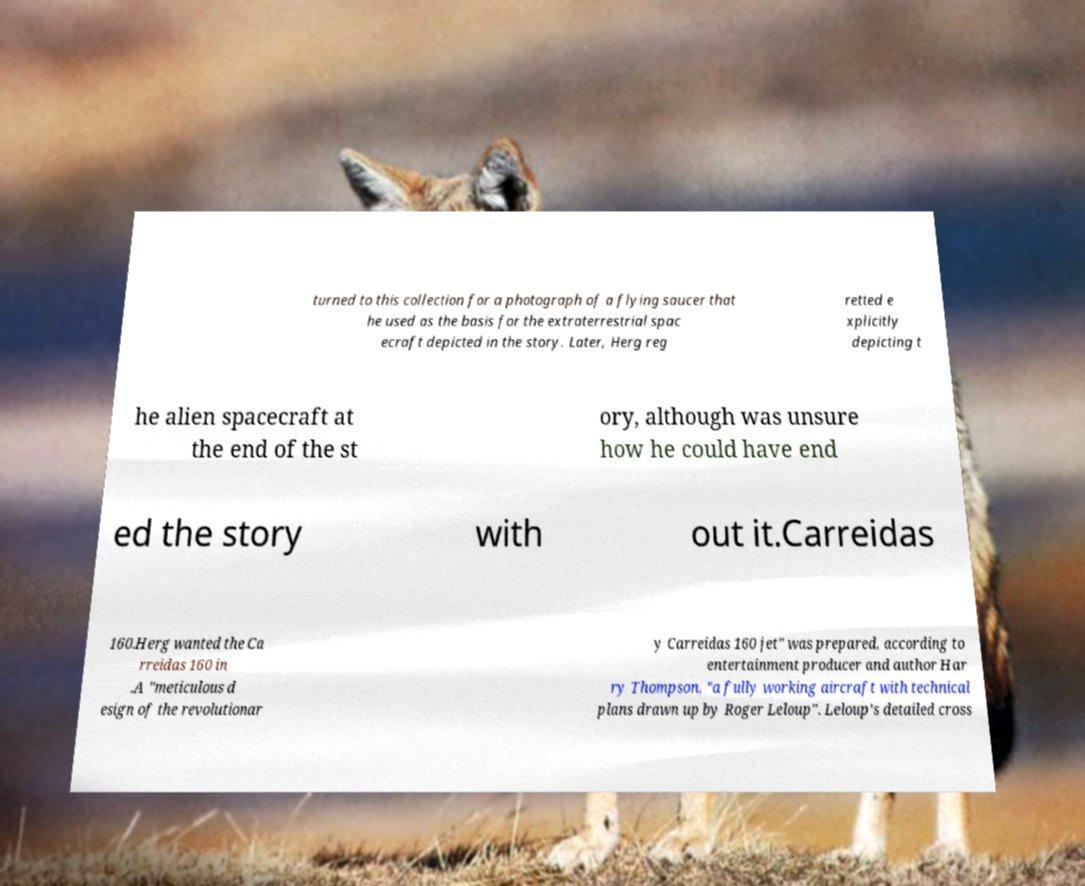There's text embedded in this image that I need extracted. Can you transcribe it verbatim? turned to this collection for a photograph of a flying saucer that he used as the basis for the extraterrestrial spac ecraft depicted in the story. Later, Herg reg retted e xplicitly depicting t he alien spacecraft at the end of the st ory, although was unsure how he could have end ed the story with out it.Carreidas 160.Herg wanted the Ca rreidas 160 in .A "meticulous d esign of the revolutionar y Carreidas 160 jet" was prepared, according to entertainment producer and author Har ry Thompson, "a fully working aircraft with technical plans drawn up by Roger Leloup". Leloup's detailed cross 